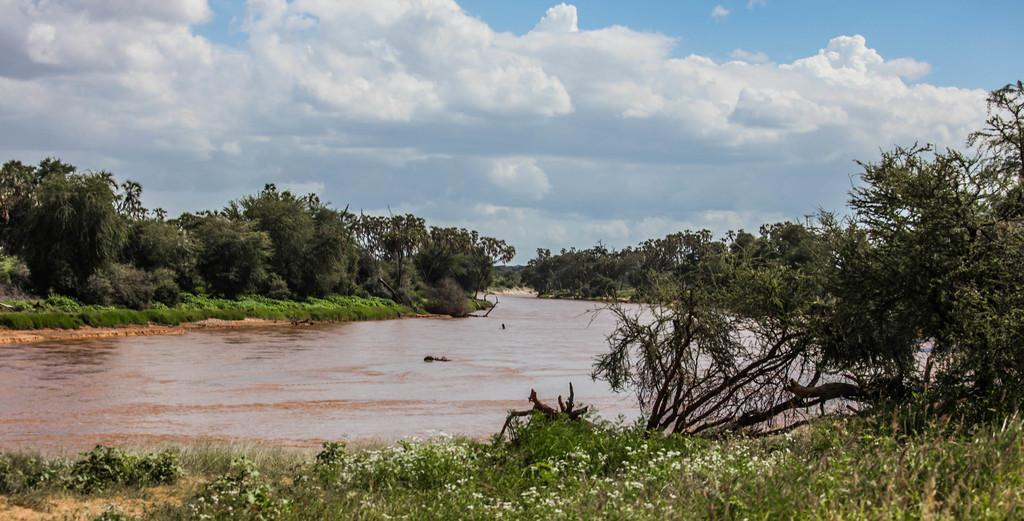What type of natural setting is shown in the image? The image depicts a lakeside. What type of vegetation can be seen in the image? There are trees and plants in the image. What type of pear is hanging from the tree in the image? There is no pear present in the image; it depicts a lakeside with trees and plants. 